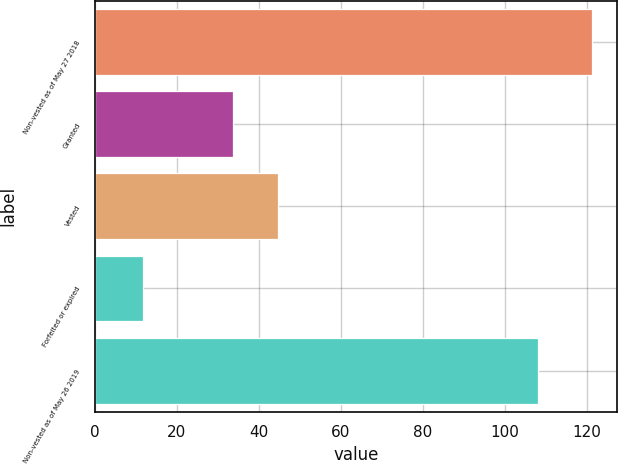Convert chart to OTSL. <chart><loc_0><loc_0><loc_500><loc_500><bar_chart><fcel>Non-vested as of May 27 2018<fcel>Granted<fcel>Vested<fcel>Forfeited or expired<fcel>Non-vested as of May 26 2019<nl><fcel>121.3<fcel>33.8<fcel>44.75<fcel>11.8<fcel>108.1<nl></chart> 